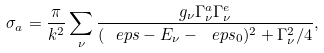<formula> <loc_0><loc_0><loc_500><loc_500>\sigma _ { a } = \frac { \pi } { k ^ { 2 } } \sum _ { \nu } \frac { g _ { \nu } \Gamma _ { \nu } ^ { a } \Gamma _ { \nu } ^ { e } } { ( \ e p s - E _ { \nu } - \ e p s _ { 0 } ) ^ { 2 } + \Gamma _ { \nu } ^ { 2 } / 4 } ,</formula> 